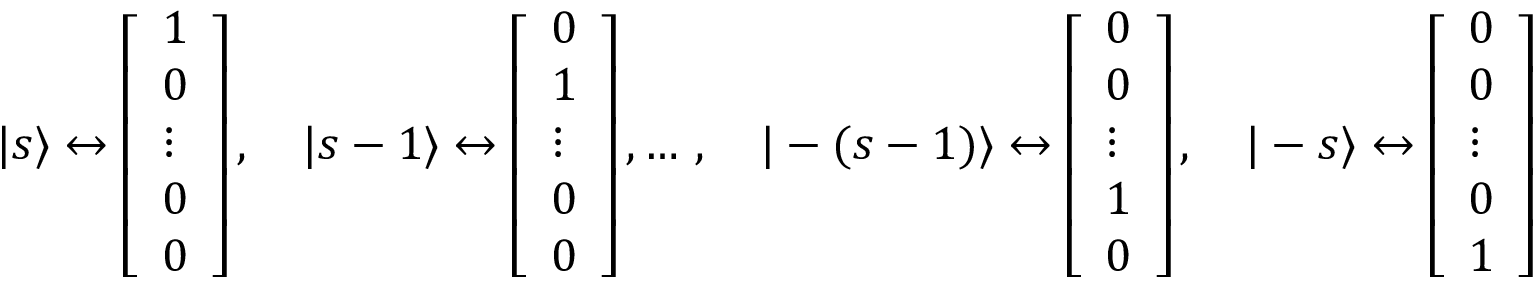<formula> <loc_0><loc_0><loc_500><loc_500>| s \rangle \leftrightarrow { \left [ \begin{array} { l } { 1 } \\ { 0 } \\ { \vdots } \\ { 0 } \\ { 0 } \end{array} \right ] } \, , \quad | s - 1 \rangle \leftrightarrow { \left [ \begin{array} { l } { 0 } \\ { 1 } \\ { \vdots } \\ { 0 } \\ { 0 } \end{array} \right ] } \, , \dots \, , \quad | - ( s - 1 ) \rangle \leftrightarrow { \left [ \begin{array} { l } { 0 } \\ { 0 } \\ { \vdots } \\ { 1 } \\ { 0 } \end{array} \right ] } \, , \quad | - s \rangle \leftrightarrow { \left [ \begin{array} { l } { 0 } \\ { 0 } \\ { \vdots } \\ { 0 } \\ { 1 } \end{array} \right ] }</formula> 